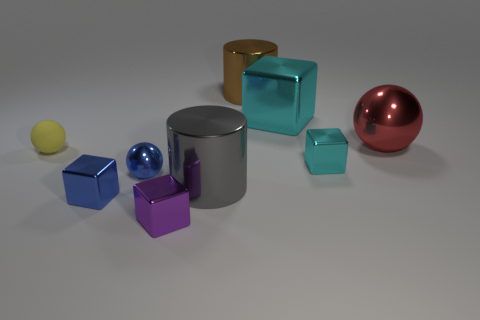How many objects are tiny red matte cylinders or large red metallic objects behind the small shiny sphere?
Keep it short and to the point. 1. Is the number of red balls that are in front of the big gray metallic cylinder greater than the number of shiny balls behind the yellow ball?
Offer a very short reply. No. What is the shape of the tiny yellow thing that is in front of the shiny object that is to the right of the tiny thing on the right side of the tiny purple metallic object?
Offer a very short reply. Sphere. There is a small metal thing to the left of the metallic ball in front of the tiny cyan shiny cube; what shape is it?
Your answer should be very brief. Cube. Is there a tiny purple cube made of the same material as the red ball?
Provide a succinct answer. Yes. What size is the metal object that is the same color as the large block?
Ensure brevity in your answer.  Small. What number of cyan objects are big spheres or cubes?
Your answer should be compact. 2. Are there any other matte spheres of the same color as the big sphere?
Provide a short and direct response. No. There is a purple block that is made of the same material as the red ball; what size is it?
Your answer should be compact. Small. How many balls are either yellow rubber objects or tiny purple objects?
Keep it short and to the point. 1. 